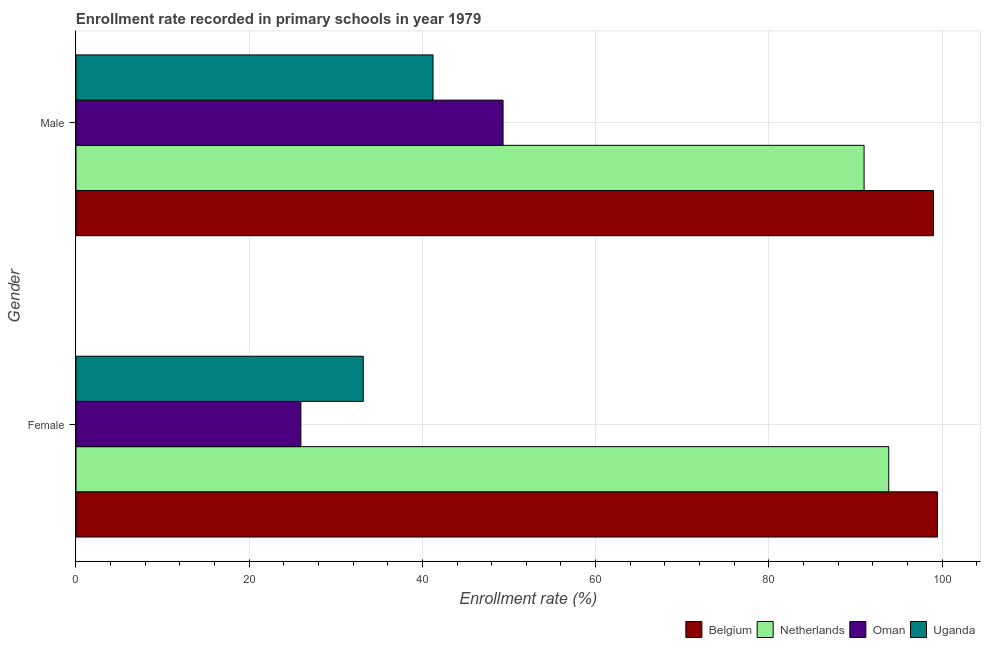How many different coloured bars are there?
Keep it short and to the point. 4. How many groups of bars are there?
Provide a succinct answer. 2. Are the number of bars per tick equal to the number of legend labels?
Your answer should be compact. Yes. What is the enrollment rate of male students in Oman?
Your response must be concise. 49.31. Across all countries, what is the maximum enrollment rate of male students?
Offer a very short reply. 99.01. Across all countries, what is the minimum enrollment rate of female students?
Provide a succinct answer. 25.97. In which country was the enrollment rate of female students minimum?
Your answer should be compact. Oman. What is the total enrollment rate of female students in the graph?
Keep it short and to the point. 252.46. What is the difference between the enrollment rate of female students in Belgium and that in Uganda?
Provide a short and direct response. 66.3. What is the difference between the enrollment rate of male students in Oman and the enrollment rate of female students in Belgium?
Your answer should be compact. -50.15. What is the average enrollment rate of female students per country?
Keep it short and to the point. 63.11. What is the difference between the enrollment rate of male students and enrollment rate of female students in Belgium?
Your answer should be compact. -0.46. In how many countries, is the enrollment rate of female students greater than 36 %?
Give a very brief answer. 2. What is the ratio of the enrollment rate of female students in Belgium to that in Oman?
Offer a terse response. 3.83. What does the 1st bar from the top in Female represents?
Your response must be concise. Uganda. What does the 2nd bar from the bottom in Male represents?
Provide a short and direct response. Netherlands. How many bars are there?
Provide a short and direct response. 8. What is the difference between two consecutive major ticks on the X-axis?
Provide a short and direct response. 20. Does the graph contain any zero values?
Provide a succinct answer. No. Does the graph contain grids?
Ensure brevity in your answer.  Yes. Where does the legend appear in the graph?
Provide a short and direct response. Bottom right. How many legend labels are there?
Offer a very short reply. 4. How are the legend labels stacked?
Make the answer very short. Horizontal. What is the title of the graph?
Offer a very short reply. Enrollment rate recorded in primary schools in year 1979. Does "Fiji" appear as one of the legend labels in the graph?
Keep it short and to the point. No. What is the label or title of the X-axis?
Ensure brevity in your answer.  Enrollment rate (%). What is the label or title of the Y-axis?
Provide a short and direct response. Gender. What is the Enrollment rate (%) of Belgium in Female?
Your answer should be very brief. 99.47. What is the Enrollment rate (%) of Netherlands in Female?
Provide a succinct answer. 93.85. What is the Enrollment rate (%) of Oman in Female?
Keep it short and to the point. 25.97. What is the Enrollment rate (%) of Uganda in Female?
Your response must be concise. 33.17. What is the Enrollment rate (%) of Belgium in Male?
Provide a succinct answer. 99.01. What is the Enrollment rate (%) in Netherlands in Male?
Provide a succinct answer. 91. What is the Enrollment rate (%) in Oman in Male?
Provide a succinct answer. 49.31. What is the Enrollment rate (%) in Uganda in Male?
Your response must be concise. 41.23. Across all Gender, what is the maximum Enrollment rate (%) of Belgium?
Provide a succinct answer. 99.47. Across all Gender, what is the maximum Enrollment rate (%) in Netherlands?
Your answer should be compact. 93.85. Across all Gender, what is the maximum Enrollment rate (%) of Oman?
Keep it short and to the point. 49.31. Across all Gender, what is the maximum Enrollment rate (%) of Uganda?
Your answer should be compact. 41.23. Across all Gender, what is the minimum Enrollment rate (%) in Belgium?
Provide a succinct answer. 99.01. Across all Gender, what is the minimum Enrollment rate (%) in Netherlands?
Your response must be concise. 91. Across all Gender, what is the minimum Enrollment rate (%) in Oman?
Give a very brief answer. 25.97. Across all Gender, what is the minimum Enrollment rate (%) of Uganda?
Provide a short and direct response. 33.17. What is the total Enrollment rate (%) of Belgium in the graph?
Your answer should be very brief. 198.48. What is the total Enrollment rate (%) in Netherlands in the graph?
Provide a succinct answer. 184.85. What is the total Enrollment rate (%) in Oman in the graph?
Keep it short and to the point. 75.28. What is the total Enrollment rate (%) of Uganda in the graph?
Provide a short and direct response. 74.4. What is the difference between the Enrollment rate (%) in Belgium in Female and that in Male?
Your answer should be compact. 0.46. What is the difference between the Enrollment rate (%) in Netherlands in Female and that in Male?
Make the answer very short. 2.85. What is the difference between the Enrollment rate (%) of Oman in Female and that in Male?
Ensure brevity in your answer.  -23.35. What is the difference between the Enrollment rate (%) of Uganda in Female and that in Male?
Provide a short and direct response. -8.05. What is the difference between the Enrollment rate (%) of Belgium in Female and the Enrollment rate (%) of Netherlands in Male?
Your answer should be very brief. 8.47. What is the difference between the Enrollment rate (%) of Belgium in Female and the Enrollment rate (%) of Oman in Male?
Your answer should be very brief. 50.16. What is the difference between the Enrollment rate (%) in Belgium in Female and the Enrollment rate (%) in Uganda in Male?
Offer a terse response. 58.24. What is the difference between the Enrollment rate (%) of Netherlands in Female and the Enrollment rate (%) of Oman in Male?
Your answer should be very brief. 44.53. What is the difference between the Enrollment rate (%) of Netherlands in Female and the Enrollment rate (%) of Uganda in Male?
Your answer should be compact. 52.62. What is the difference between the Enrollment rate (%) of Oman in Female and the Enrollment rate (%) of Uganda in Male?
Provide a short and direct response. -15.26. What is the average Enrollment rate (%) of Belgium per Gender?
Give a very brief answer. 99.24. What is the average Enrollment rate (%) of Netherlands per Gender?
Keep it short and to the point. 92.43. What is the average Enrollment rate (%) in Oman per Gender?
Give a very brief answer. 37.64. What is the average Enrollment rate (%) in Uganda per Gender?
Offer a terse response. 37.2. What is the difference between the Enrollment rate (%) of Belgium and Enrollment rate (%) of Netherlands in Female?
Ensure brevity in your answer.  5.62. What is the difference between the Enrollment rate (%) of Belgium and Enrollment rate (%) of Oman in Female?
Offer a very short reply. 73.5. What is the difference between the Enrollment rate (%) in Belgium and Enrollment rate (%) in Uganda in Female?
Your answer should be compact. 66.3. What is the difference between the Enrollment rate (%) of Netherlands and Enrollment rate (%) of Oman in Female?
Your answer should be very brief. 67.88. What is the difference between the Enrollment rate (%) in Netherlands and Enrollment rate (%) in Uganda in Female?
Offer a very short reply. 60.68. What is the difference between the Enrollment rate (%) of Oman and Enrollment rate (%) of Uganda in Female?
Provide a succinct answer. -7.2. What is the difference between the Enrollment rate (%) of Belgium and Enrollment rate (%) of Netherlands in Male?
Give a very brief answer. 8.01. What is the difference between the Enrollment rate (%) of Belgium and Enrollment rate (%) of Oman in Male?
Your response must be concise. 49.7. What is the difference between the Enrollment rate (%) in Belgium and Enrollment rate (%) in Uganda in Male?
Provide a short and direct response. 57.78. What is the difference between the Enrollment rate (%) in Netherlands and Enrollment rate (%) in Oman in Male?
Provide a succinct answer. 41.69. What is the difference between the Enrollment rate (%) in Netherlands and Enrollment rate (%) in Uganda in Male?
Provide a succinct answer. 49.77. What is the difference between the Enrollment rate (%) of Oman and Enrollment rate (%) of Uganda in Male?
Ensure brevity in your answer.  8.09. What is the ratio of the Enrollment rate (%) of Belgium in Female to that in Male?
Provide a succinct answer. 1. What is the ratio of the Enrollment rate (%) of Netherlands in Female to that in Male?
Your response must be concise. 1.03. What is the ratio of the Enrollment rate (%) of Oman in Female to that in Male?
Make the answer very short. 0.53. What is the ratio of the Enrollment rate (%) in Uganda in Female to that in Male?
Your answer should be very brief. 0.8. What is the difference between the highest and the second highest Enrollment rate (%) in Belgium?
Give a very brief answer. 0.46. What is the difference between the highest and the second highest Enrollment rate (%) of Netherlands?
Provide a succinct answer. 2.85. What is the difference between the highest and the second highest Enrollment rate (%) in Oman?
Your response must be concise. 23.35. What is the difference between the highest and the second highest Enrollment rate (%) of Uganda?
Your answer should be compact. 8.05. What is the difference between the highest and the lowest Enrollment rate (%) of Belgium?
Provide a short and direct response. 0.46. What is the difference between the highest and the lowest Enrollment rate (%) of Netherlands?
Make the answer very short. 2.85. What is the difference between the highest and the lowest Enrollment rate (%) in Oman?
Give a very brief answer. 23.35. What is the difference between the highest and the lowest Enrollment rate (%) in Uganda?
Provide a succinct answer. 8.05. 